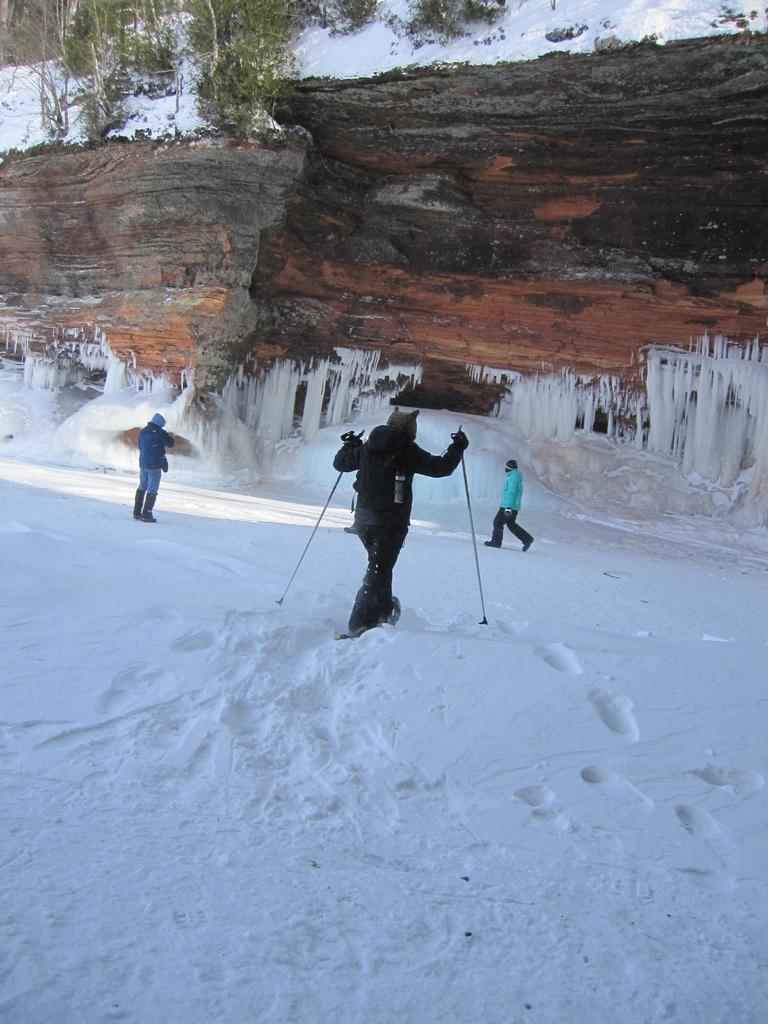In one or two sentences, can you explain what this image depicts? In the center of the image we can see a person skiing on the snow. In the background there are people, hill and trees. 